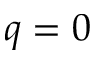<formula> <loc_0><loc_0><loc_500><loc_500>q = 0</formula> 